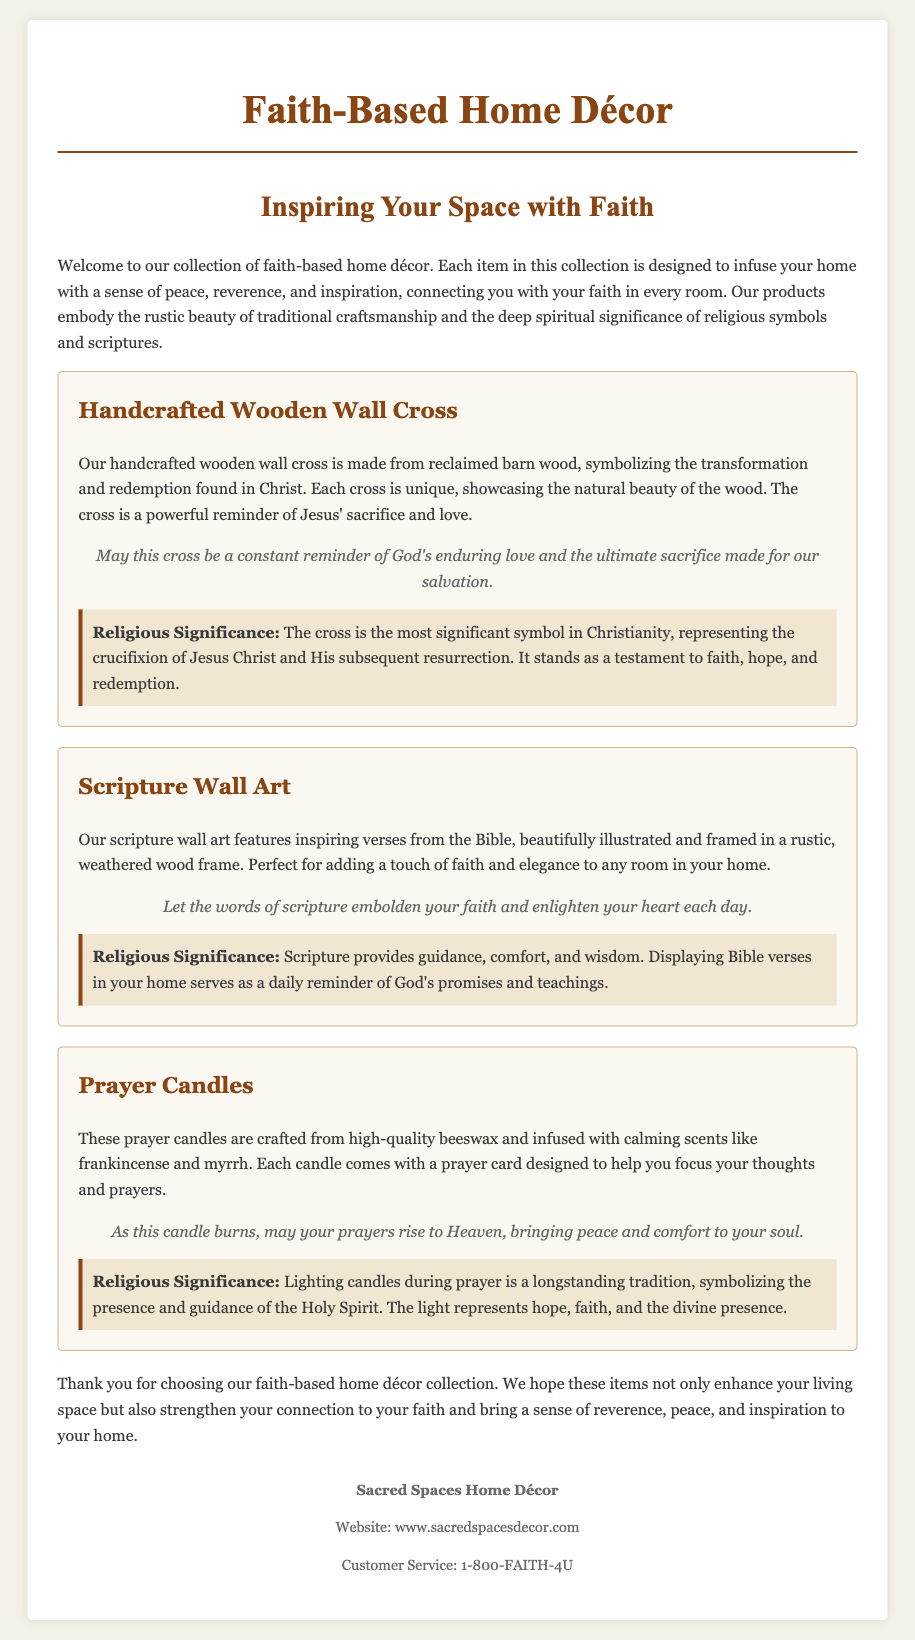What is the name of the collection? The name of the collection is mentioned in the title of the document.
Answer: Faith-Based Home Décor What natural material is used for the handcrafted wooden wall cross? The type of material is specified in the description of the handcrafted wooden wall cross.
Answer: Reclaimed barn wood What is the main purpose of the scripture wall art? The purpose is indicated in the description of the scripture wall art.
Answer: Adding a touch of faith and elegance What is infused in the prayer candles? The infused products are listed in the description for the prayer candles.
Answer: Calming scents like frankincense and myrrh What does the cross symbolize according to the document? The document mentions the symbolism associated with the cross in its description.
Answer: Transformation and redemption How does lighting candles during prayer serve in religious practice? The significance of lighting candles is explained in the significance section of the prayer candles.
Answer: Symbolizing the presence and guidance of the Holy Spirit What type of frame is used for the scripture wall art? The type of frame is described in the product section for scripture wall art.
Answer: Rustic, weathered wood frame What message is included with each prayer candle? The document specifies the additional item that comes with each prayer candle.
Answer: A prayer card What is the intended effect of the wall cross as per the message? The intended effect is detailed in the message associated with the handcrafted wooden wall cross.
Answer: A constant reminder of God's enduring love 